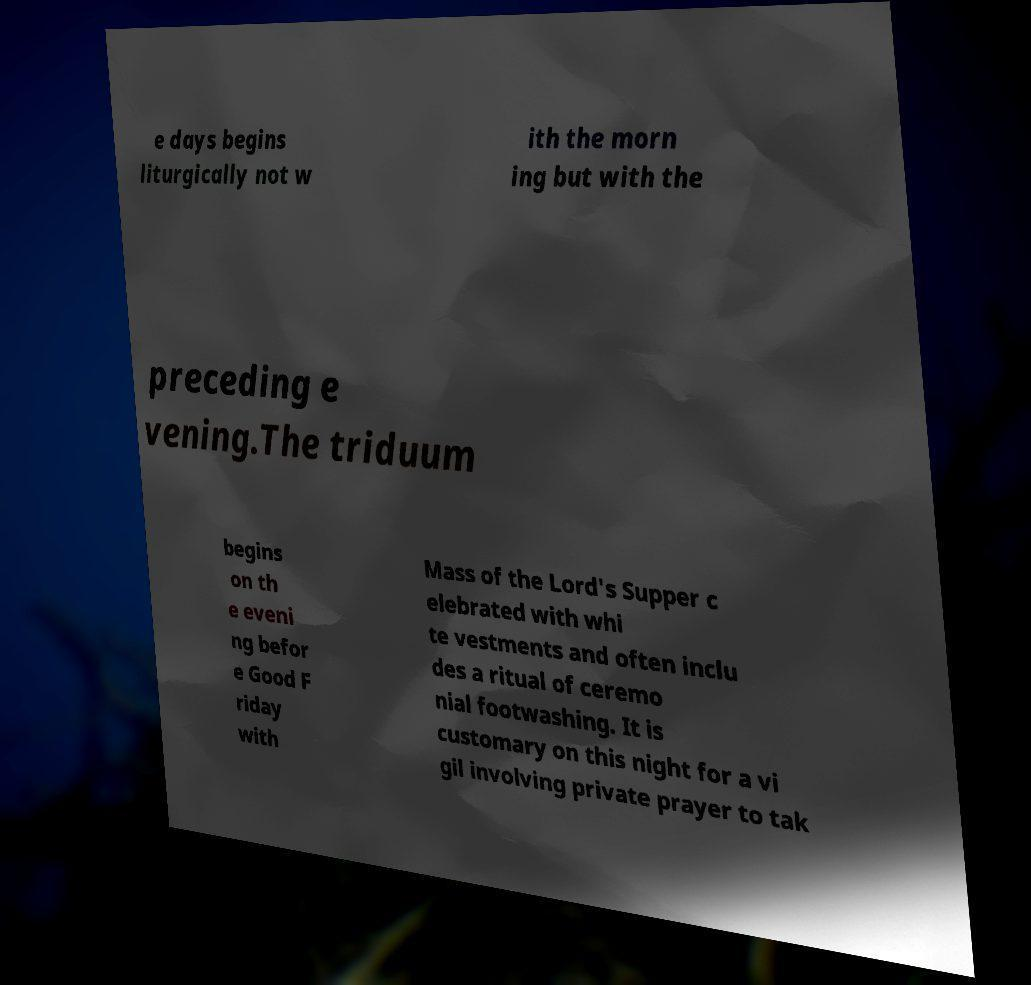What messages or text are displayed in this image? I need them in a readable, typed format. e days begins liturgically not w ith the morn ing but with the preceding e vening.The triduum begins on th e eveni ng befor e Good F riday with Mass of the Lord's Supper c elebrated with whi te vestments and often inclu des a ritual of ceremo nial footwashing. It is customary on this night for a vi gil involving private prayer to tak 